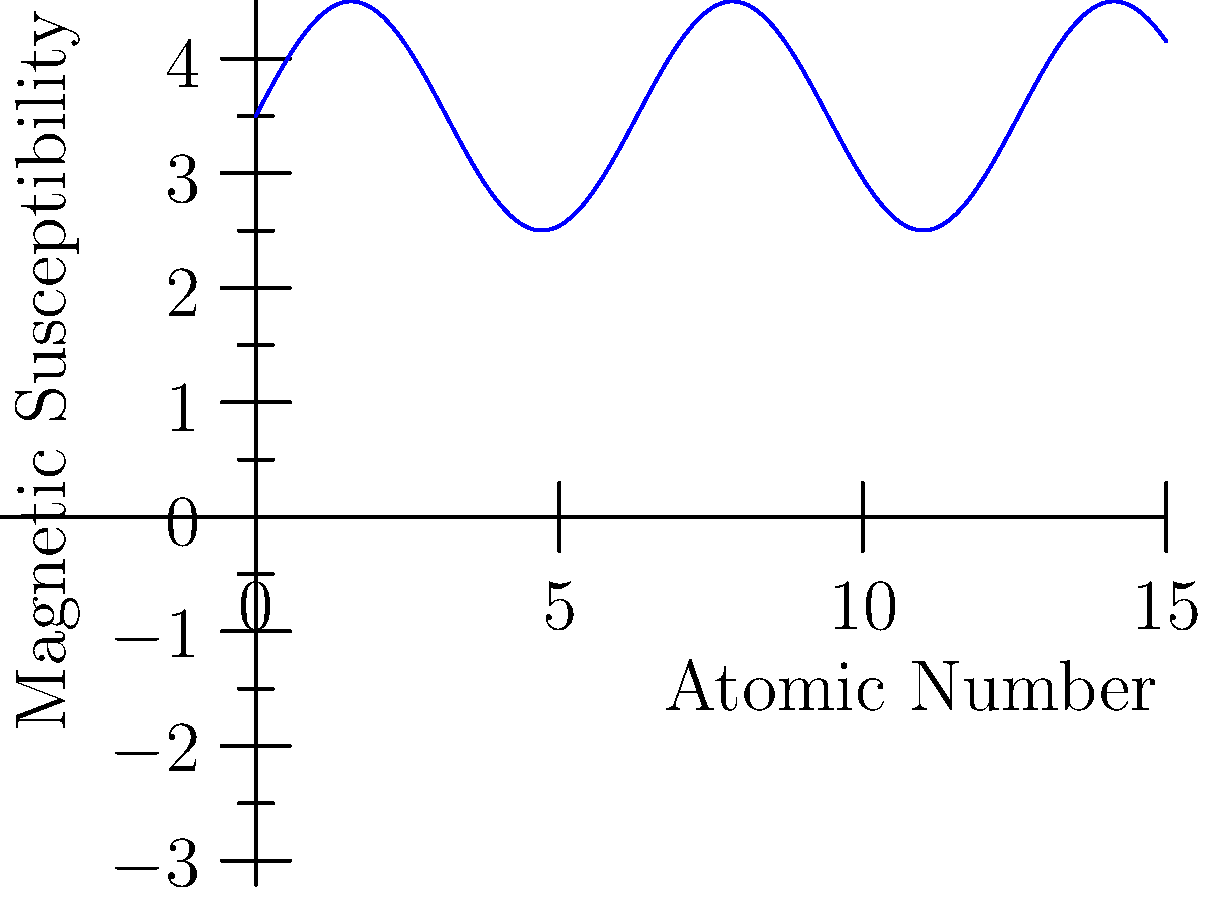The graph shows the variation in magnetic susceptibility of lanthanide complexes with increasing atomic number. Which element corresponds to the peak in magnetic susceptibility, and what property of this element explains this observation? To answer this question, we need to analyze the graph and recall the electronic configuration of lanthanides:

1. The graph shows a peak in magnetic susceptibility around the middle of the lanthanide series.

2. This peak corresponds to the element gadolinium (Gd), which is labeled on the graph.

3. The electronic configuration of Gd is [Xe]4f^7 5d^1 6s^2.

4. In the 4f subshell, Gd has 7 unpaired electrons, which is the maximum possible for f-orbitals.

5. According to Hund's rule, the maximum number of unpaired electrons results in the highest magnetic moment.

6. The magnetic susceptibility is directly proportional to the magnetic moment.

7. Therefore, Gd exhibits the highest magnetic susceptibility due to its half-filled 4f subshell.

8. Elements before and after Gd in the series have fewer unpaired electrons, resulting in lower magnetic susceptibilities.

The property that explains this observation is the half-filled 4f subshell of gadolinium, which results in the maximum number of unpaired electrons (7) for lanthanides.
Answer: Gadolinium (Gd); half-filled 4f subshell 